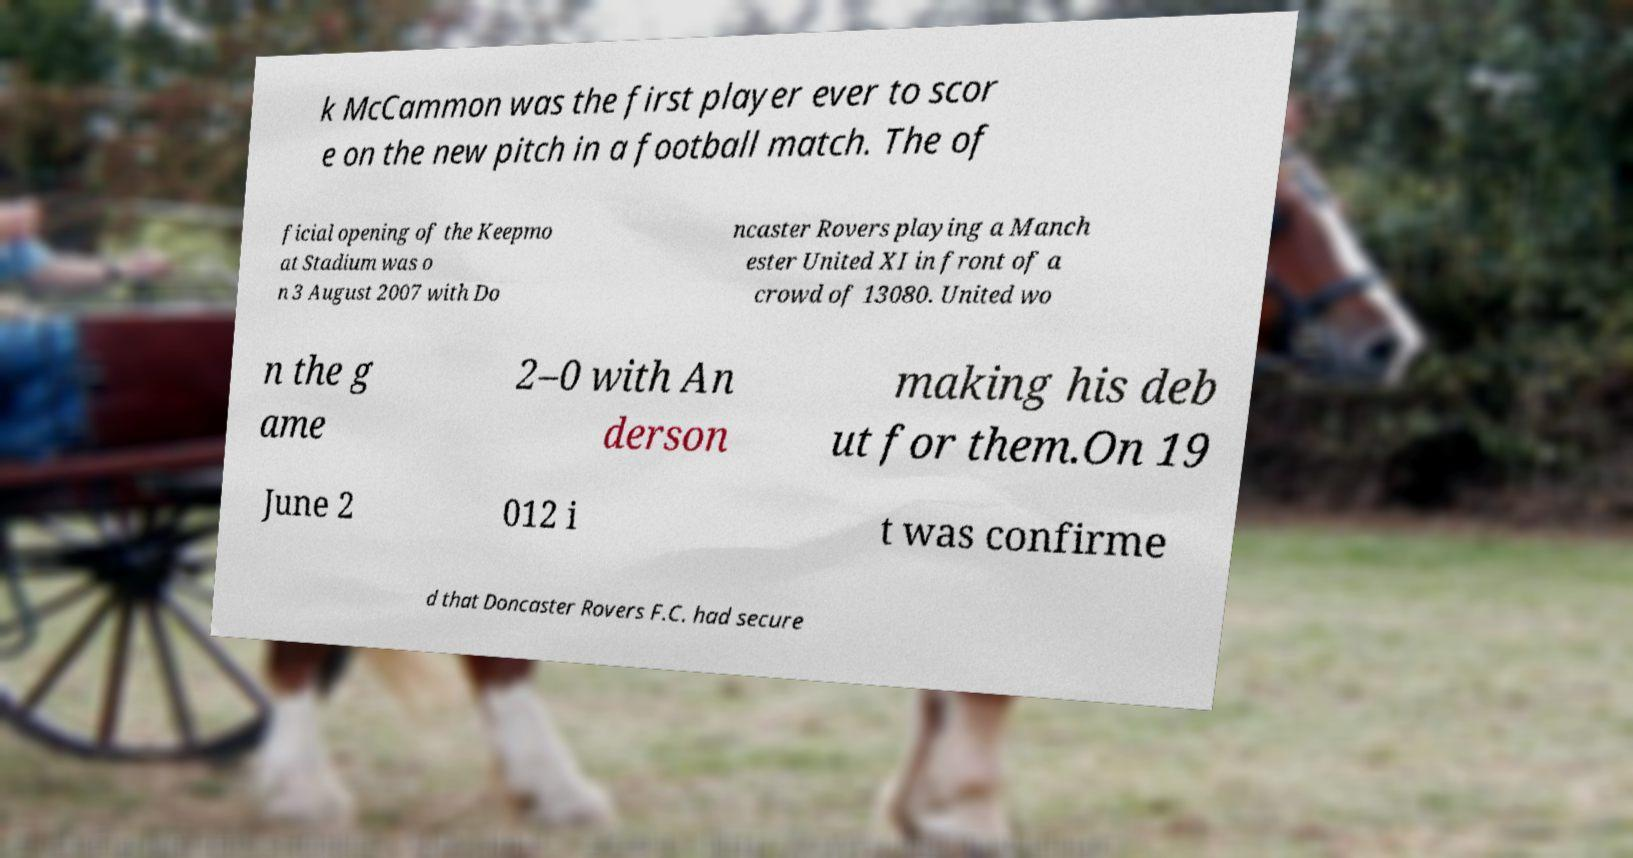There's text embedded in this image that I need extracted. Can you transcribe it verbatim? k McCammon was the first player ever to scor e on the new pitch in a football match. The of ficial opening of the Keepmo at Stadium was o n 3 August 2007 with Do ncaster Rovers playing a Manch ester United XI in front of a crowd of 13080. United wo n the g ame 2–0 with An derson making his deb ut for them.On 19 June 2 012 i t was confirme d that Doncaster Rovers F.C. had secure 